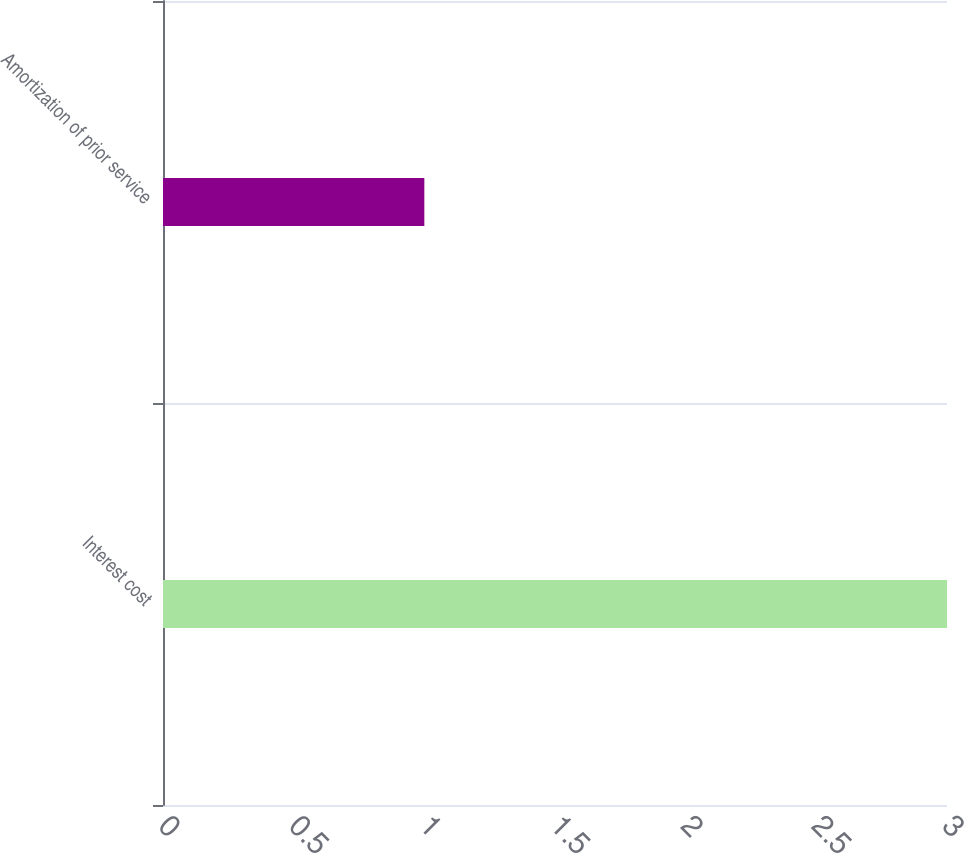Convert chart to OTSL. <chart><loc_0><loc_0><loc_500><loc_500><bar_chart><fcel>Interest cost<fcel>Amortization of prior service<nl><fcel>3<fcel>1<nl></chart> 